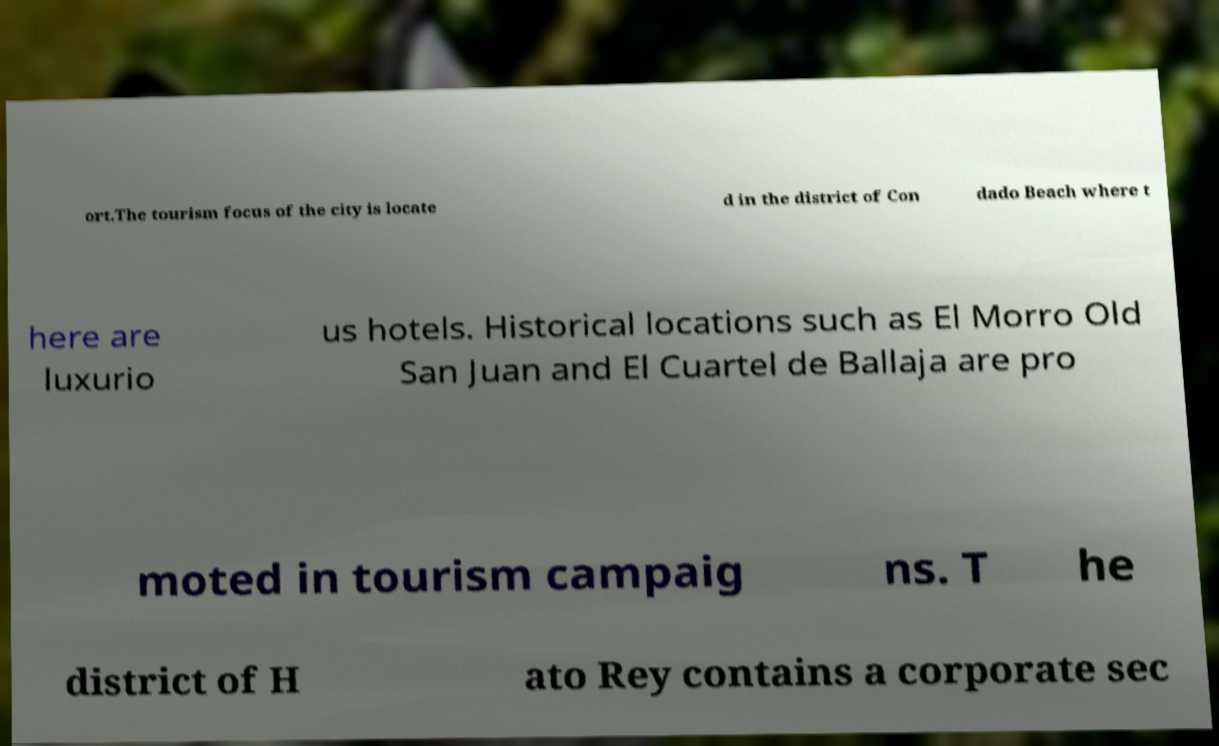There's text embedded in this image that I need extracted. Can you transcribe it verbatim? ort.The tourism focus of the city is locate d in the district of Con dado Beach where t here are luxurio us hotels. Historical locations such as El Morro Old San Juan and El Cuartel de Ballaja are pro moted in tourism campaig ns. T he district of H ato Rey contains a corporate sec 